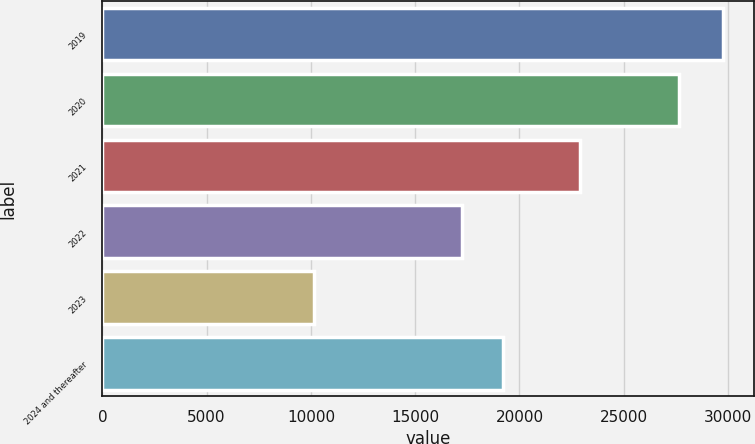Convert chart. <chart><loc_0><loc_0><loc_500><loc_500><bar_chart><fcel>2019<fcel>2020<fcel>2021<fcel>2022<fcel>2023<fcel>2024 and thereafter<nl><fcel>29739<fcel>27669<fcel>22904<fcel>17240<fcel>10166<fcel>19197.3<nl></chart> 